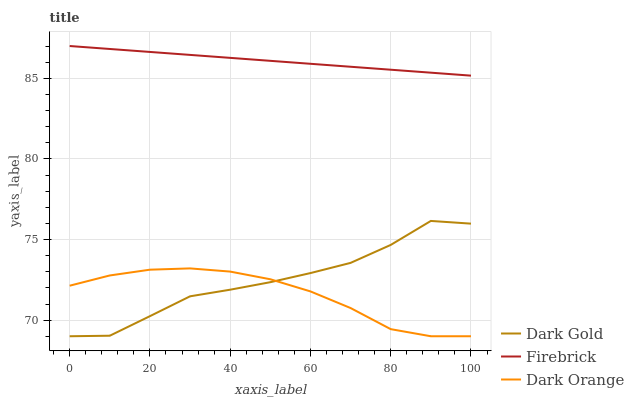Does Dark Orange have the minimum area under the curve?
Answer yes or no. Yes. Does Firebrick have the maximum area under the curve?
Answer yes or no. Yes. Does Dark Gold have the minimum area under the curve?
Answer yes or no. No. Does Dark Gold have the maximum area under the curve?
Answer yes or no. No. Is Firebrick the smoothest?
Answer yes or no. Yes. Is Dark Gold the roughest?
Answer yes or no. Yes. Is Dark Gold the smoothest?
Answer yes or no. No. Is Firebrick the roughest?
Answer yes or no. No. Does Firebrick have the lowest value?
Answer yes or no. No. Does Firebrick have the highest value?
Answer yes or no. Yes. Does Dark Gold have the highest value?
Answer yes or no. No. Is Dark Orange less than Firebrick?
Answer yes or no. Yes. Is Firebrick greater than Dark Orange?
Answer yes or no. Yes. Does Dark Gold intersect Dark Orange?
Answer yes or no. Yes. Is Dark Gold less than Dark Orange?
Answer yes or no. No. Is Dark Gold greater than Dark Orange?
Answer yes or no. No. Does Dark Orange intersect Firebrick?
Answer yes or no. No. 